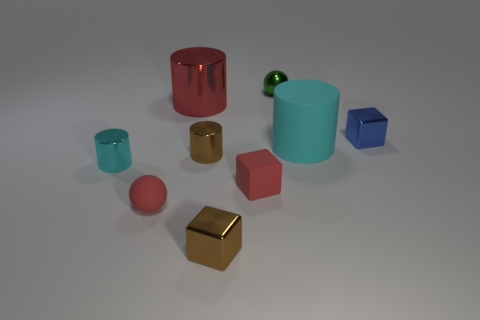There is a rubber cylinder; is it the same color as the small object behind the big metallic cylinder?
Give a very brief answer. No. How big is the metal object that is to the left of the small blue block and right of the small red rubber cube?
Make the answer very short. Small. How many other objects are the same color as the big matte thing?
Ensure brevity in your answer.  1. What size is the cube behind the matte object that is behind the cyan cylinder that is to the left of the brown cylinder?
Your response must be concise. Small. There is a cyan shiny cylinder; are there any tiny metal cubes to the left of it?
Offer a terse response. No. Is the size of the blue shiny thing the same as the thing on the left side of the red ball?
Provide a succinct answer. Yes. What number of other things are the same material as the red cylinder?
Provide a short and direct response. 5. There is a object that is behind the cyan rubber object and right of the tiny green ball; what shape is it?
Your answer should be very brief. Cube. Is the size of the matte thing that is to the left of the big red thing the same as the metallic cube on the right side of the metal ball?
Ensure brevity in your answer.  Yes. The cyan thing that is the same material as the big red cylinder is what shape?
Give a very brief answer. Cylinder. 